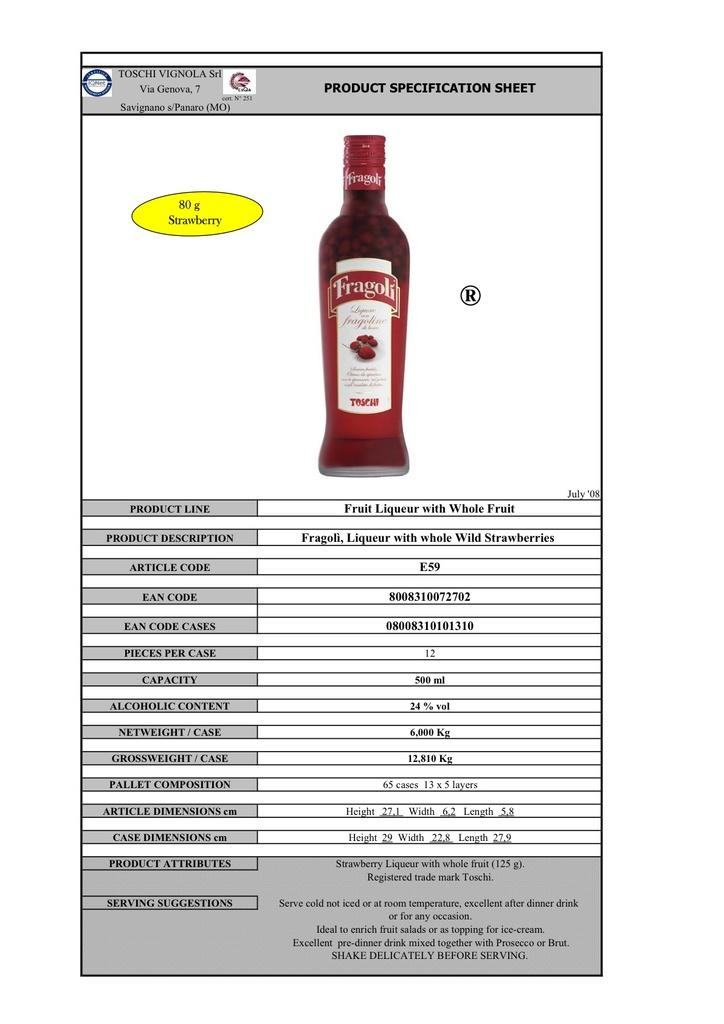<image>
Give a short and clear explanation of the subsequent image. A product specification sheet for Toschi Vignola fruit liqueur says the article code is E59. 